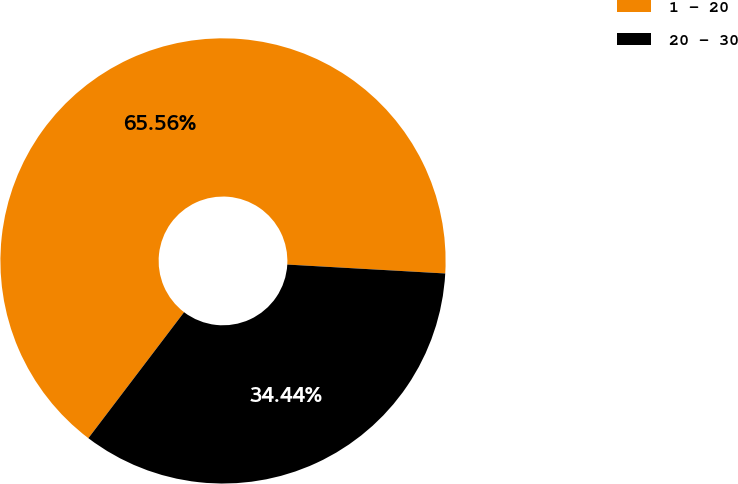<chart> <loc_0><loc_0><loc_500><loc_500><pie_chart><fcel>1 - 20<fcel>20 - 30<nl><fcel>65.56%<fcel>34.44%<nl></chart> 